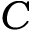Convert formula to latex. <formula><loc_0><loc_0><loc_500><loc_500>C</formula> 